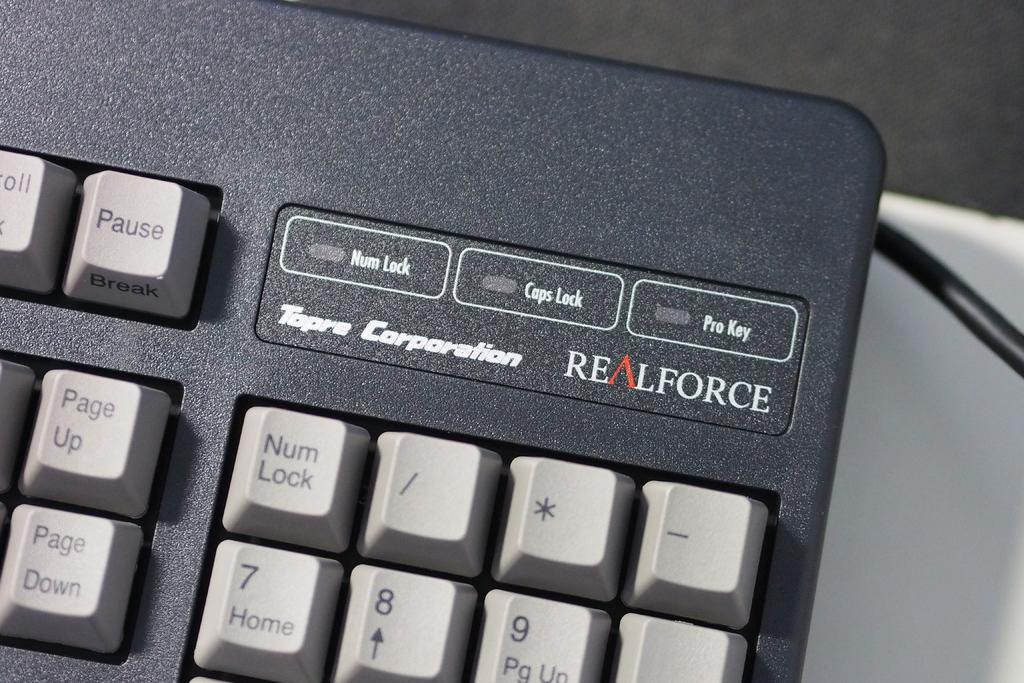<image>
Create a compact narrative representing the image presented. A close up of the top right hand corner of a realforce keyboard. 